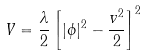Convert formula to latex. <formula><loc_0><loc_0><loc_500><loc_500>V = \frac { \lambda } { 2 } \left [ | \phi | ^ { 2 } - \frac { v ^ { 2 } } { 2 } \right ] ^ { 2 }</formula> 